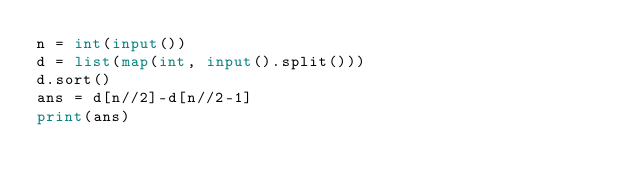<code> <loc_0><loc_0><loc_500><loc_500><_Python_>n = int(input())
d = list(map(int, input().split()))
d.sort()
ans = d[n//2]-d[n//2-1]
print(ans)</code> 